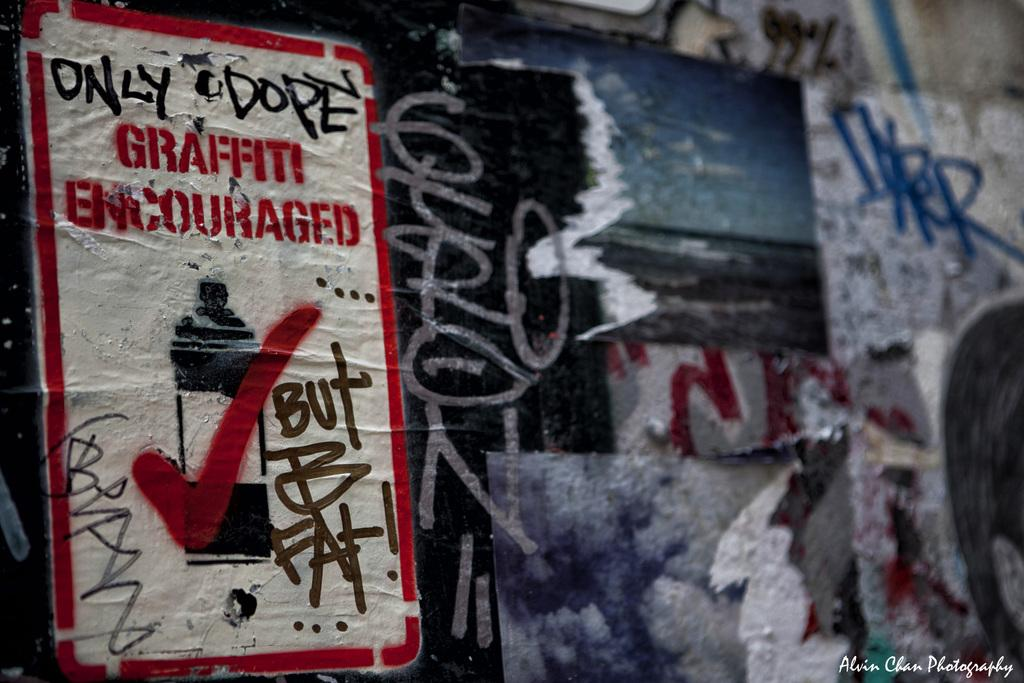<image>
Share a concise interpretation of the image provided. A sign covered in graffiti reads graffiti encouraged. 